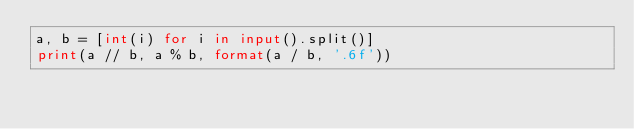<code> <loc_0><loc_0><loc_500><loc_500><_Python_>a, b = [int(i) for i in input().split()]
print(a // b, a % b, format(a / b, '.6f'))</code> 